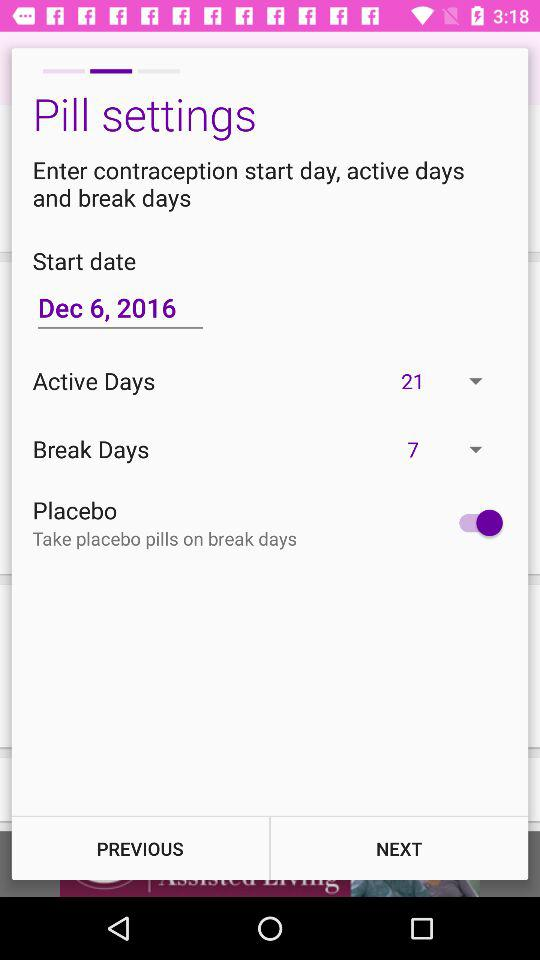When do we have to take placebo pills? We have to take placebo pills on break days. 